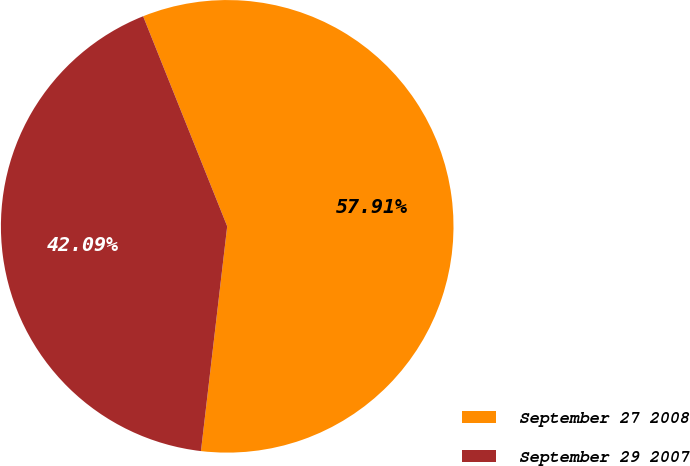Convert chart to OTSL. <chart><loc_0><loc_0><loc_500><loc_500><pie_chart><fcel>September 27 2008<fcel>September 29 2007<nl><fcel>57.91%<fcel>42.09%<nl></chart> 